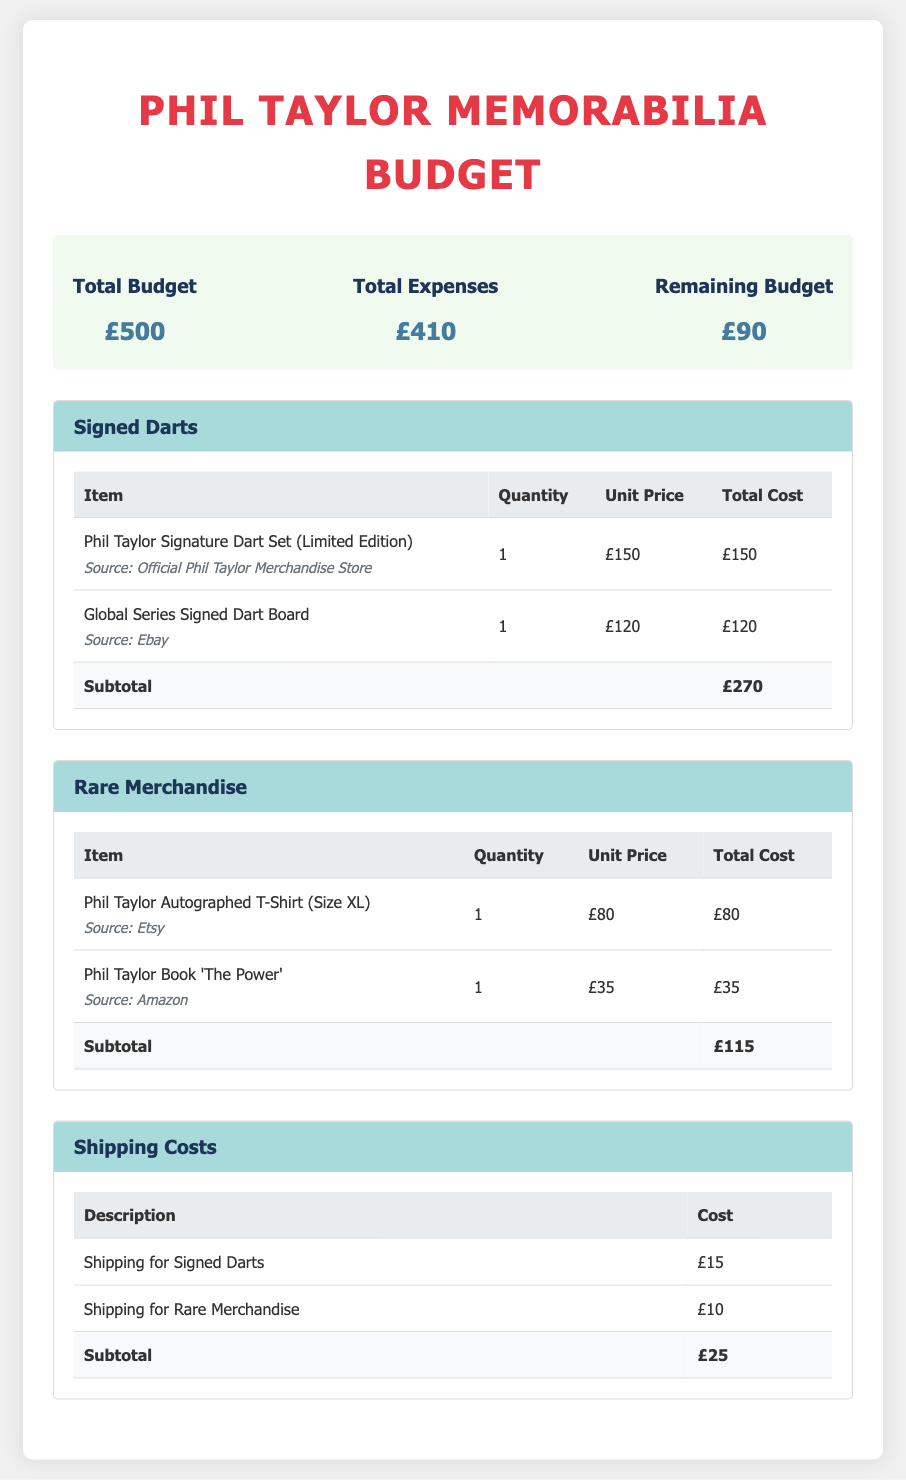What is the total budget for March 2023? The total budget is stated clearly in the budget summary section of the document.
Answer: £500 What is the total expenses for the month? The total expenses are summarized in the budget summary and represent the total spending for the month.
Answer: £410 What is the remaining budget after expenses? The remaining budget is calculated by subtracting total expenses from total budget and is found in the budget summary.
Answer: £90 How much is the Phil Taylor Signature Dart Set? The unit price for the Phil Taylor Signature Dart Set is listed in the signed darts section under its respective row.
Answer: £150 What is the subtotal for rare merchandise? This value represents the total for all items in the rare merchandise category and is displayed at the bottom of the table in that section.
Answer: £115 What are the shipping costs for signed darts? The shipping cost for signed darts is provided in the shipping costs table within the document.
Answer: £15 What is the total cost for shipping? The total shipping cost is summarized at the end of the shipping costs table in the document.
Answer: £25 How many signed darts are included in the budget? The quantity of signed darts is mentioned in the respective section’s table, referring to the total amount of signed darts purchased.
Answer: 2 Which source lists the Phil Taylor Autographed T-Shirt? The source for this item can be found in the description area of the rare merchandise table, specifying where it was sourced.
Answer: Etsy 